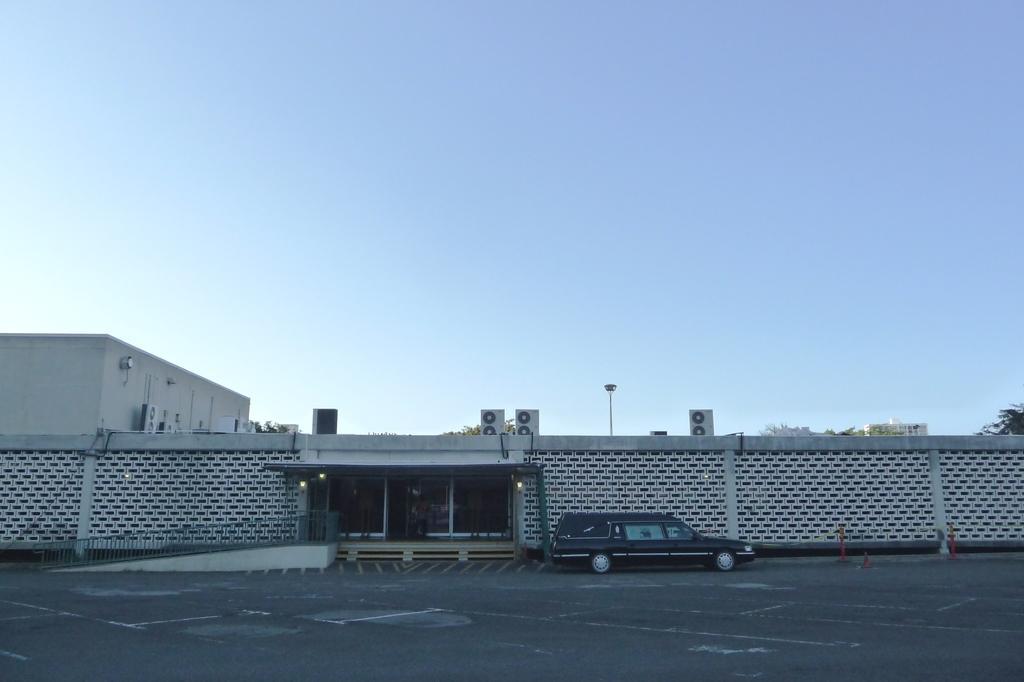How would you summarize this image in a sentence or two? In this image, we can see buildings, trees and we can see lights, a pole and there are glass doors and some people. At the bottom, there is a vehicle some traffic cones on the road. At the top, there is sky. 